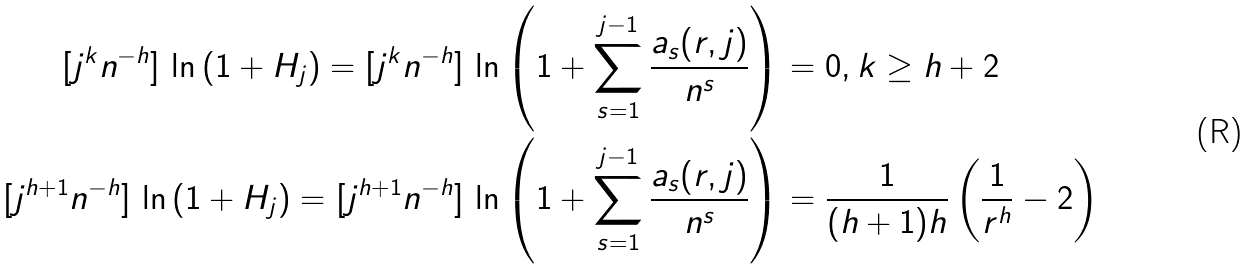<formula> <loc_0><loc_0><loc_500><loc_500>[ j ^ { k } n ^ { - h } ] \, \ln \left ( 1 + H _ { j } \right ) = [ j ^ { k } n ^ { - h } ] \, \ln \left ( 1 + \sum _ { s = 1 } ^ { j - 1 } \frac { a _ { s } ( r , j ) } { n ^ { s } } \right ) & = 0 , k \geq h + 2 \\ [ j ^ { h + 1 } n ^ { - h } ] \, \ln \left ( 1 + H _ { j } \right ) = [ j ^ { h + 1 } n ^ { - h } ] \, \ln \left ( 1 + \sum _ { s = 1 } ^ { j - 1 } \frac { a _ { s } ( r , j ) } { n ^ { s } } \right ) & = \frac { 1 } { ( h + 1 ) h } \left ( \frac { 1 } { r ^ { h } } - 2 \right )</formula> 